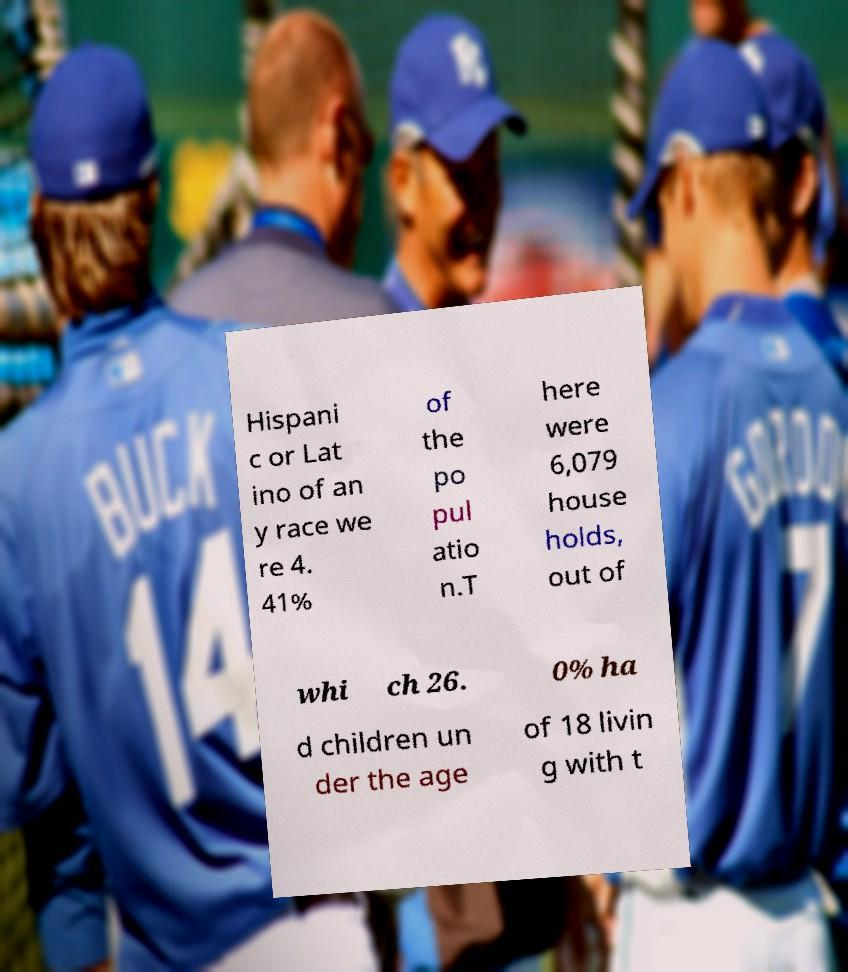There's text embedded in this image that I need extracted. Can you transcribe it verbatim? Hispani c or Lat ino of an y race we re 4. 41% of the po pul atio n.T here were 6,079 house holds, out of whi ch 26. 0% ha d children un der the age of 18 livin g with t 